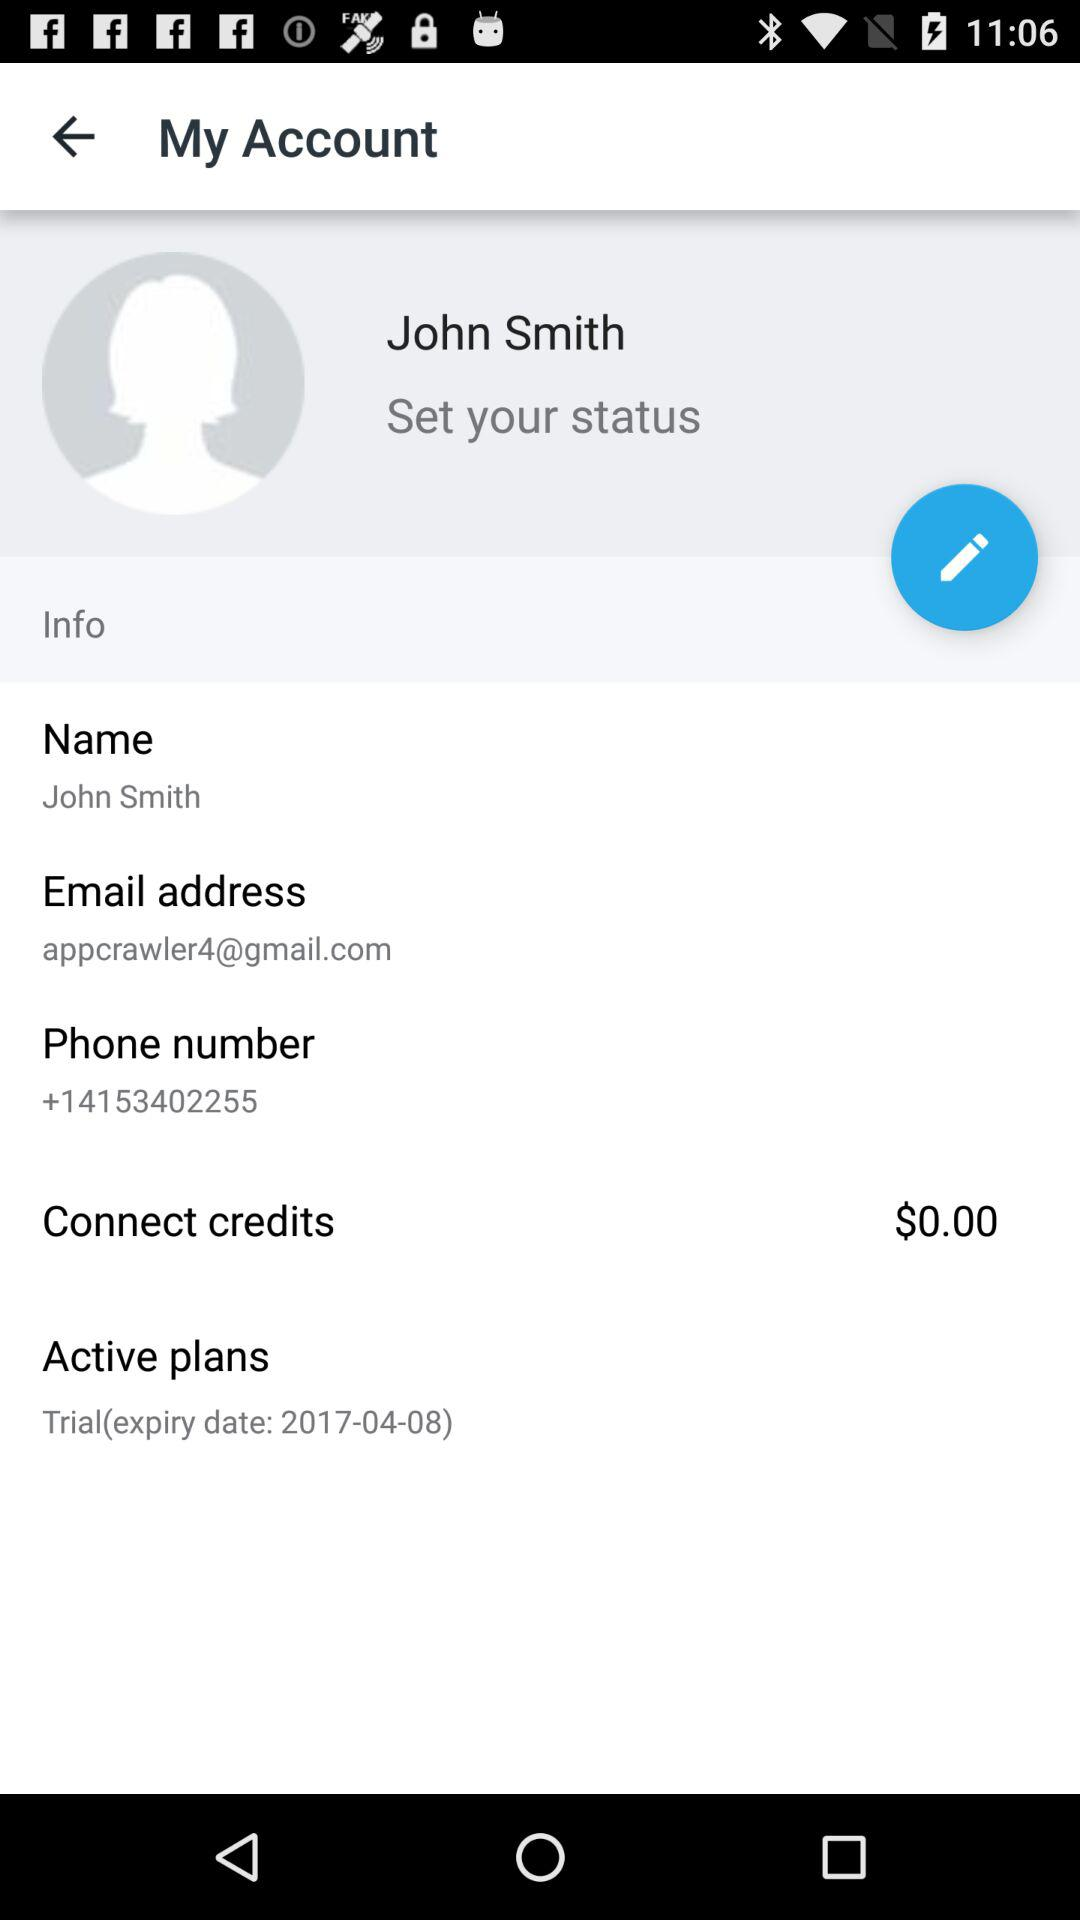What is the amount in "Connect credits"? The amount in "Connect credits" is 0 dollars. 